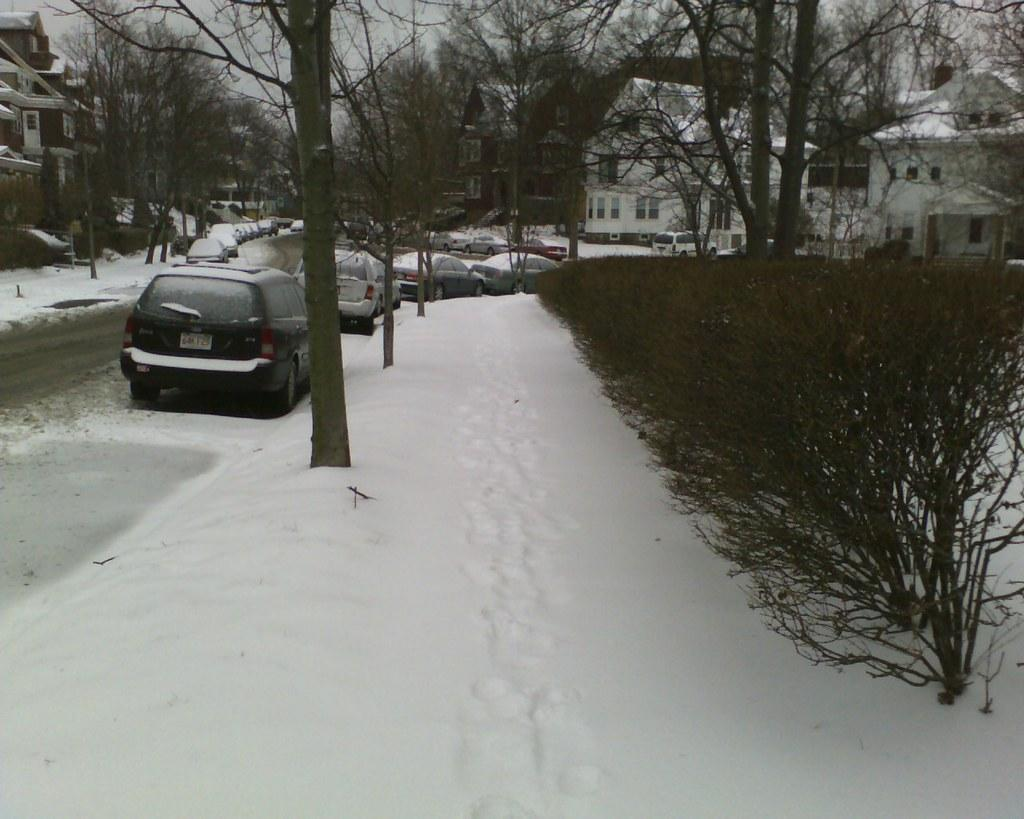What can be seen in the image besides the background? There are vehicles in the image. What type of natural elements can be seen in the background of the image? There are trees, buildings, and bushes in the background of the image. What is the weather condition in the image? There is snow at the bottom of the image, indicating a cold or snowy weather condition. What type of sticks can be seen in the image? There are no sticks present in the image. What is the color of the copper in the image? There is no copper present in the image. 